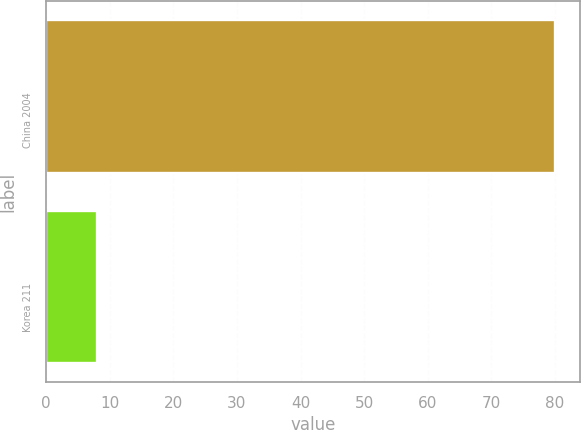<chart> <loc_0><loc_0><loc_500><loc_500><bar_chart><fcel>China 2004<fcel>Korea 211<nl><fcel>80<fcel>8<nl></chart> 